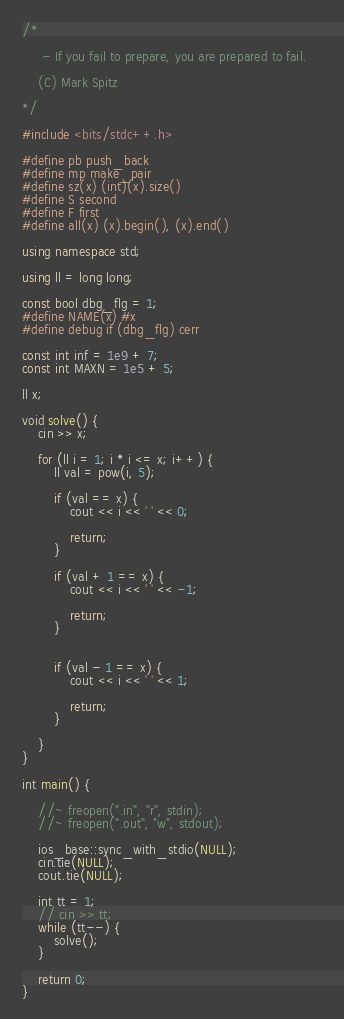<code> <loc_0><loc_0><loc_500><loc_500><_C++_>/* 

	 - If you fail to prepare, you are prepared to fail.	

	(C) Mark Spitz

*/

#include <bits/stdc++.h>

#define pb push_back
#define mp make_pair
#define sz(x) (int)(x).size()
#define S second
#define F first
#define all(x) (x).begin(), (x).end()

using namespace std;

using ll = long long;

const bool dbg_flg = 1;
#define NAME(x) #x
#define debug if (dbg_flg) cerr

const int inf = 1e9 + 7;
const int MAXN = 1e5 + 5;

ll x;

void solve() {
	cin >> x;

	for (ll i = 1; i * i <= x; i++) {
		ll val = pow(i, 5);

		if (val == x) {
			cout << i << ' ' << 0;
			
			return;
		}
		
		if (val + 1 == x) {
			cout << i << ' ' << -1;			
			
			return;
		}


		if (val - 1 == x) {
			cout << i << ' ' << 1;

			return;
		}

	}
}

int main() {
	
	//~ freopen(".in", "r", stdin);
	//~ freopen(".out", "w", stdout);
	
	ios_base::sync_with_stdio(NULL);
	cin.tie(NULL);
	cout.tie(NULL);

	int tt = 1;
	// cin >> tt;
	while (tt--) {
		solve();
	}

	return 0;
}</code> 